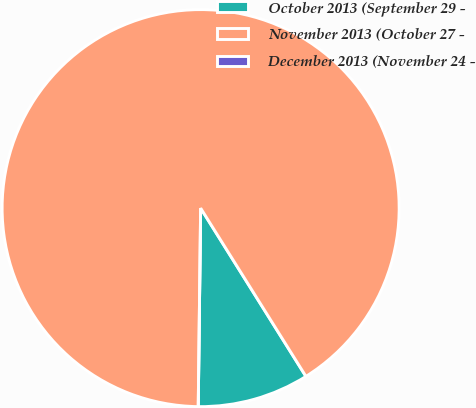Convert chart. <chart><loc_0><loc_0><loc_500><loc_500><pie_chart><fcel>October 2013 (September 29 -<fcel>November 2013 (October 27 -<fcel>December 2013 (November 24 -<nl><fcel>9.09%<fcel>90.9%<fcel>0.0%<nl></chart> 